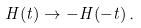Convert formula to latex. <formula><loc_0><loc_0><loc_500><loc_500>H ( t ) \to - H ( - t ) \, .</formula> 